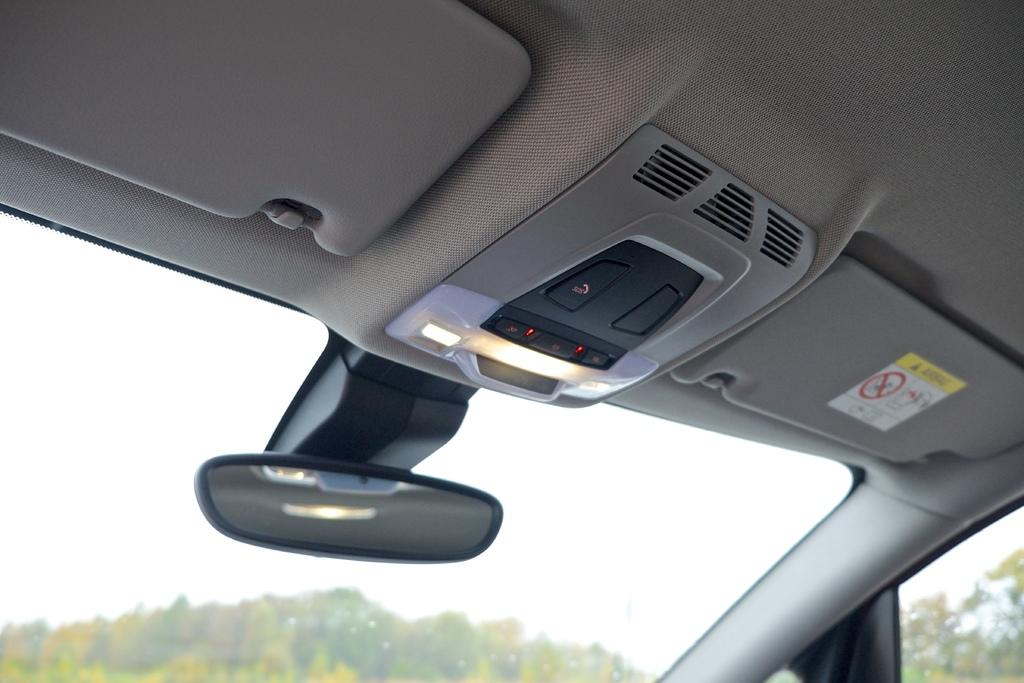What type of setting is depicted in the image? The image is an inside view of a car. What can be seen at the front of the car in the image? There is a windshield at the bottom of the image. What feature is present to help the driver see behind the car? There is a rear-view mirror in the image. What controls might be available for the driver to operate the car? There are switches visible in the image. Can you tell me how many tigers are sitting in the back seat of the car in the image? There are no tigers present in the image; it is an inside view of a car with no visible animals. 